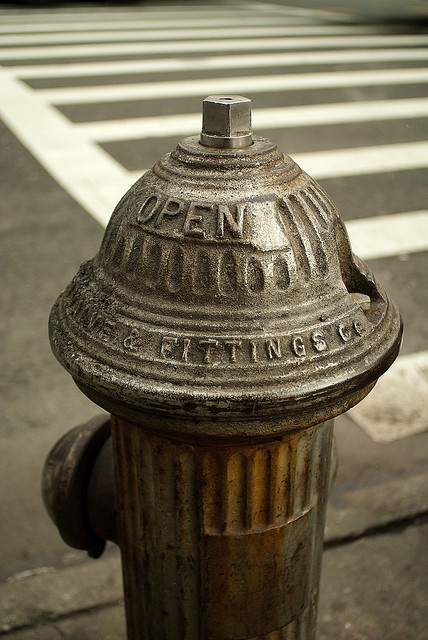Describe the objects in this image and their specific colors. I can see a fire hydrant in black and gray tones in this image. 